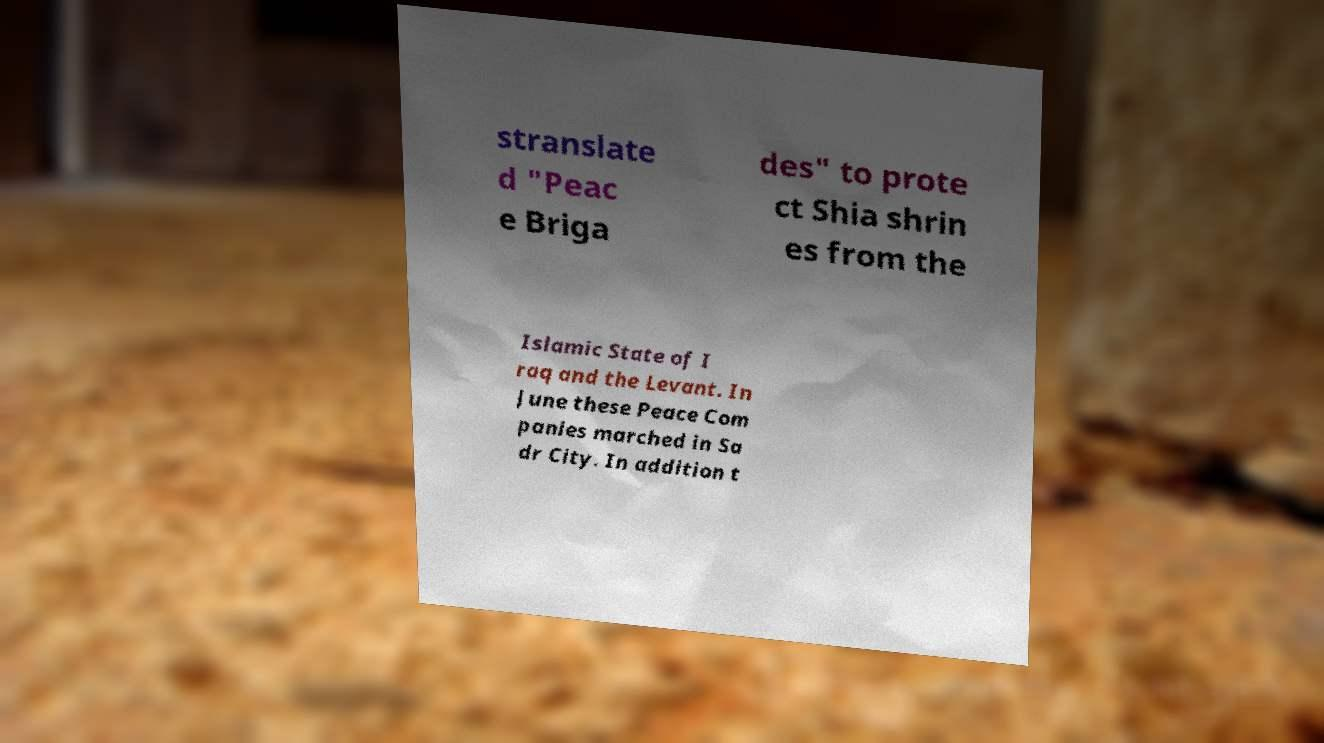For documentation purposes, I need the text within this image transcribed. Could you provide that? stranslate d "Peac e Briga des" to prote ct Shia shrin es from the Islamic State of I raq and the Levant. In June these Peace Com panies marched in Sa dr City. In addition t 